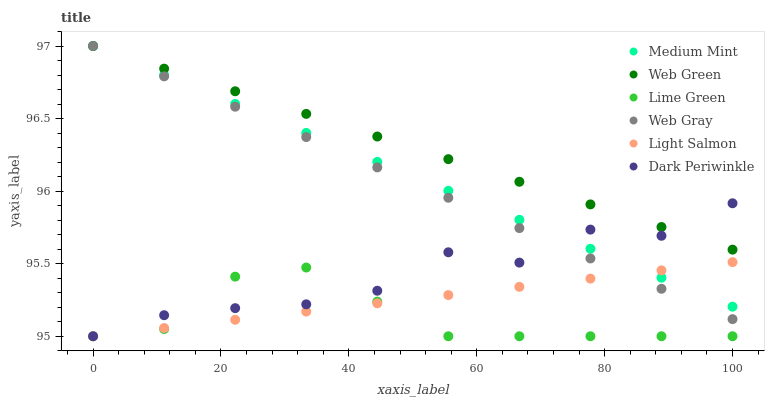Does Lime Green have the minimum area under the curve?
Answer yes or no. Yes. Does Web Green have the maximum area under the curve?
Answer yes or no. Yes. Does Light Salmon have the minimum area under the curve?
Answer yes or no. No. Does Light Salmon have the maximum area under the curve?
Answer yes or no. No. Is Web Green the smoothest?
Answer yes or no. Yes. Is Dark Periwinkle the roughest?
Answer yes or no. Yes. Is Light Salmon the smoothest?
Answer yes or no. No. Is Light Salmon the roughest?
Answer yes or no. No. Does Light Salmon have the lowest value?
Answer yes or no. Yes. Does Web Gray have the lowest value?
Answer yes or no. No. Does Web Green have the highest value?
Answer yes or no. Yes. Does Light Salmon have the highest value?
Answer yes or no. No. Is Lime Green less than Medium Mint?
Answer yes or no. Yes. Is Web Green greater than Light Salmon?
Answer yes or no. Yes. Does Web Green intersect Dark Periwinkle?
Answer yes or no. Yes. Is Web Green less than Dark Periwinkle?
Answer yes or no. No. Is Web Green greater than Dark Periwinkle?
Answer yes or no. No. Does Lime Green intersect Medium Mint?
Answer yes or no. No. 